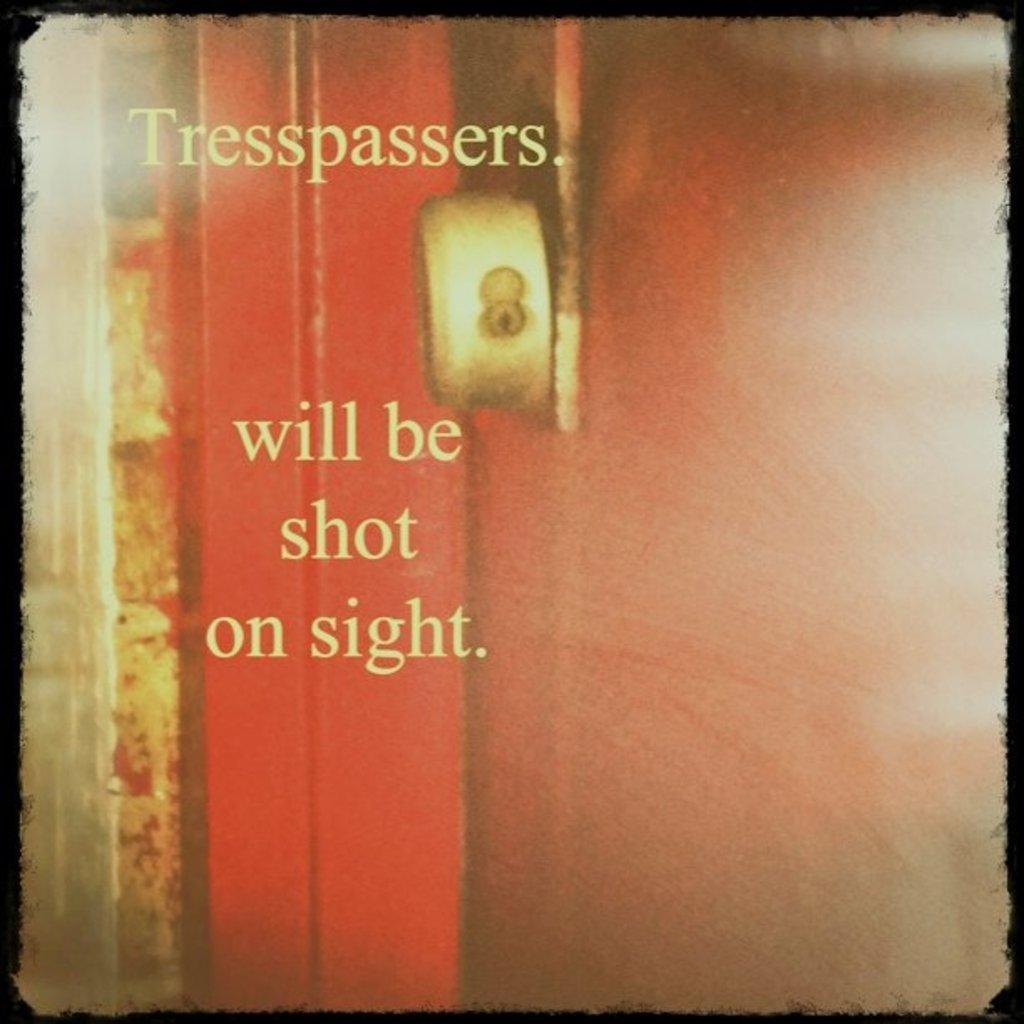Provide a one-sentence caption for the provided image. The paper warned that trespassers will be shot on sight. 